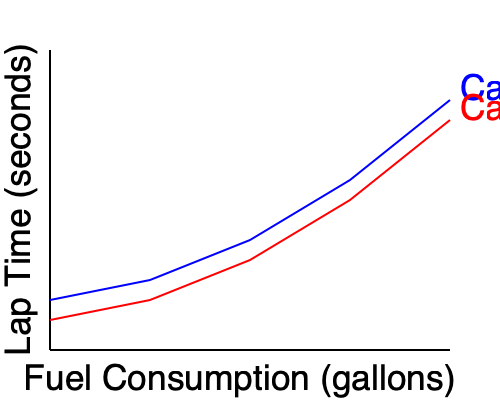As a NASCAR driver, you're analyzing the performance of two cars (A and B) during a race. The graph shows lap times versus fuel consumption for both cars. If both cars start with 50 gallons of fuel and the race is 200 laps long, which car would likely require fewer pit stops, and why? To determine which car would likely require fewer pit stops, we need to analyze the relationship between fuel consumption and lap times for both cars:

1. Observe the graph:
   - Car A (blue line) has lower lap times overall compared to Car B (red line).
   - Car A's fuel consumption increases more rapidly than Car B's.

2. Estimate fuel consumption per lap:
   - At 50 gallons (graph's maximum), Car A's lap time is about 100 seconds.
   - At 50 gallons, Car B's lap time is about 120 seconds.
   - This suggests Car A uses more fuel per lap than Car B.

3. Consider race length:
   - The race is 200 laps long.
   - Car B, while slower, appears to be more fuel-efficient.

4. Pit stop strategy:
   - Fewer pit stops mean less time lost in the pits.
   - However, this advantage must be balanced against on-track performance.

5. Conclusion:
   - Car B would likely require fewer pit stops due to its better fuel efficiency.
   - This could be advantageous if the time saved from fewer pit stops outweighs the slower lap times.

As a NASCAR driver, you'd need to weigh the trade-off between speed and fuel efficiency. In this case, Car B's fuel efficiency might give it an edge in pit stop strategy, potentially requiring fewer stops over the 200-lap race.
Answer: Car B, due to better fuel efficiency. 